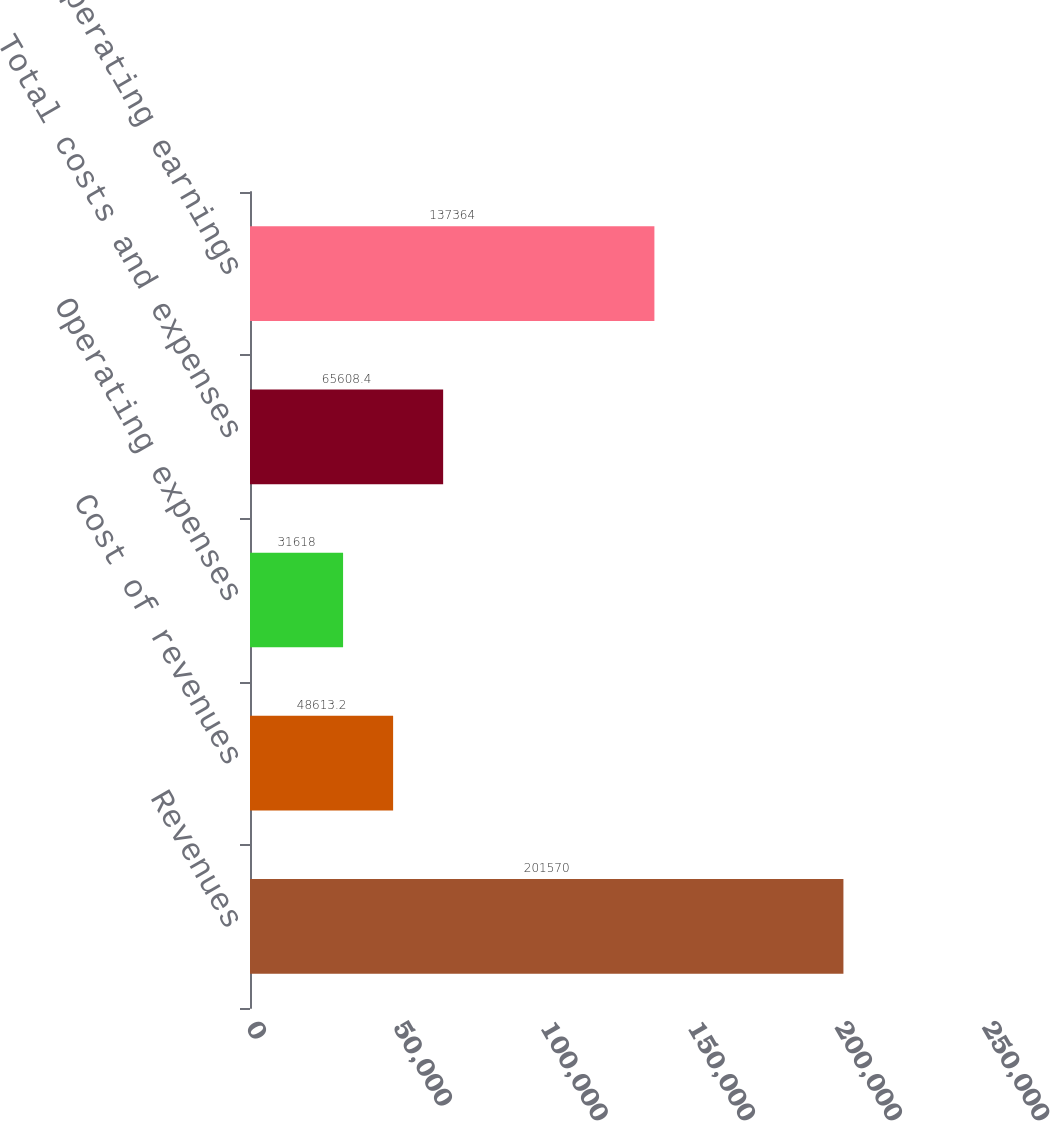Convert chart. <chart><loc_0><loc_0><loc_500><loc_500><bar_chart><fcel>Revenues<fcel>Cost of revenues<fcel>Operating expenses<fcel>Total costs and expenses<fcel>Operating earnings<nl><fcel>201570<fcel>48613.2<fcel>31618<fcel>65608.4<fcel>137364<nl></chart> 